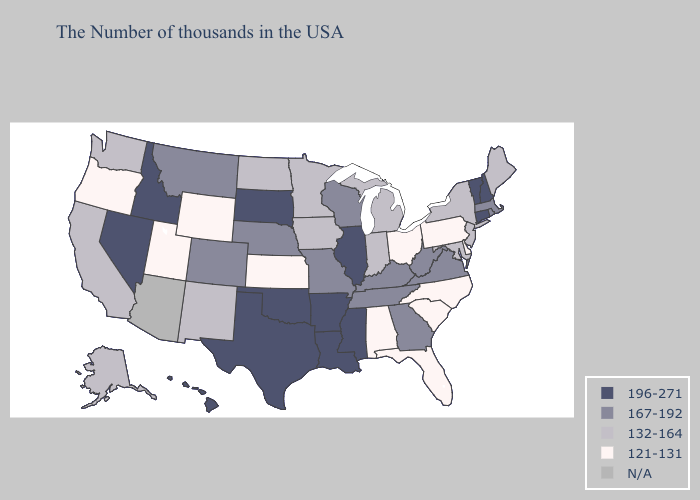Name the states that have a value in the range 167-192?
Give a very brief answer. Massachusetts, Rhode Island, Virginia, West Virginia, Georgia, Kentucky, Tennessee, Wisconsin, Missouri, Nebraska, Colorado, Montana. Does Vermont have the lowest value in the Northeast?
Concise answer only. No. What is the highest value in states that border Oregon?
Short answer required. 196-271. What is the value of New Mexico?
Concise answer only. 132-164. What is the value of Pennsylvania?
Be succinct. 121-131. What is the value of Alabama?
Write a very short answer. 121-131. Does the first symbol in the legend represent the smallest category?
Give a very brief answer. No. What is the value of Wisconsin?
Be succinct. 167-192. Does the map have missing data?
Short answer required. Yes. What is the lowest value in states that border New Hampshire?
Keep it brief. 132-164. Does Maryland have the highest value in the USA?
Keep it brief. No. What is the lowest value in the USA?
Short answer required. 121-131. What is the value of Nevada?
Be succinct. 196-271. What is the value of Virginia?
Write a very short answer. 167-192. 